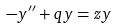Convert formula to latex. <formula><loc_0><loc_0><loc_500><loc_500>- y ^ { \prime \prime } + q y = z y</formula> 